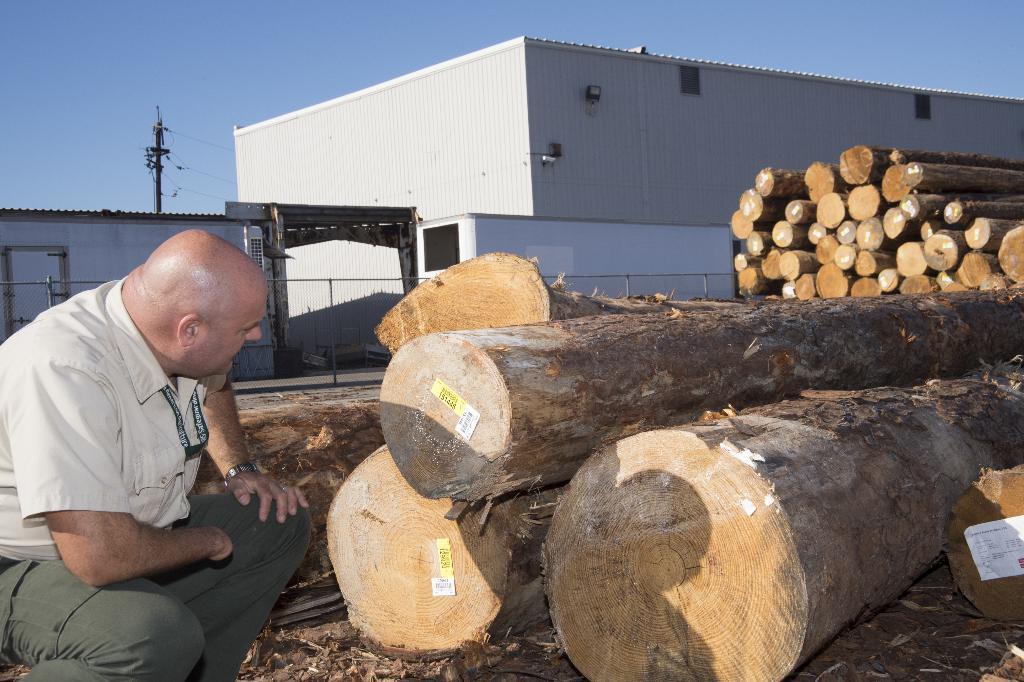Describe this image in one or two sentences. This picture shows large tree barks with tags on the barks and we see a man seeing the tree barks and we see a building and an electrical pole and we see a blue cloudy Sky. 